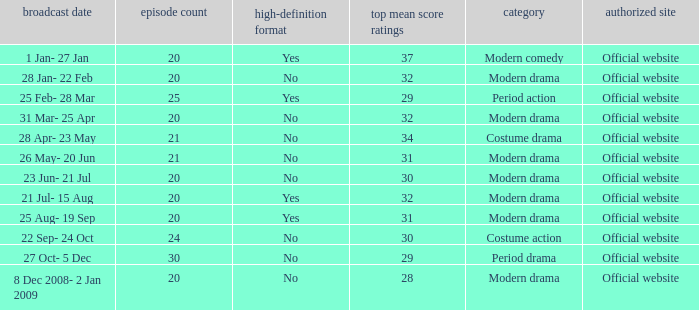What was the airing date when the number of episodes was larger than 20 and had the genre of costume action? 22 Sep- 24 Oct. 